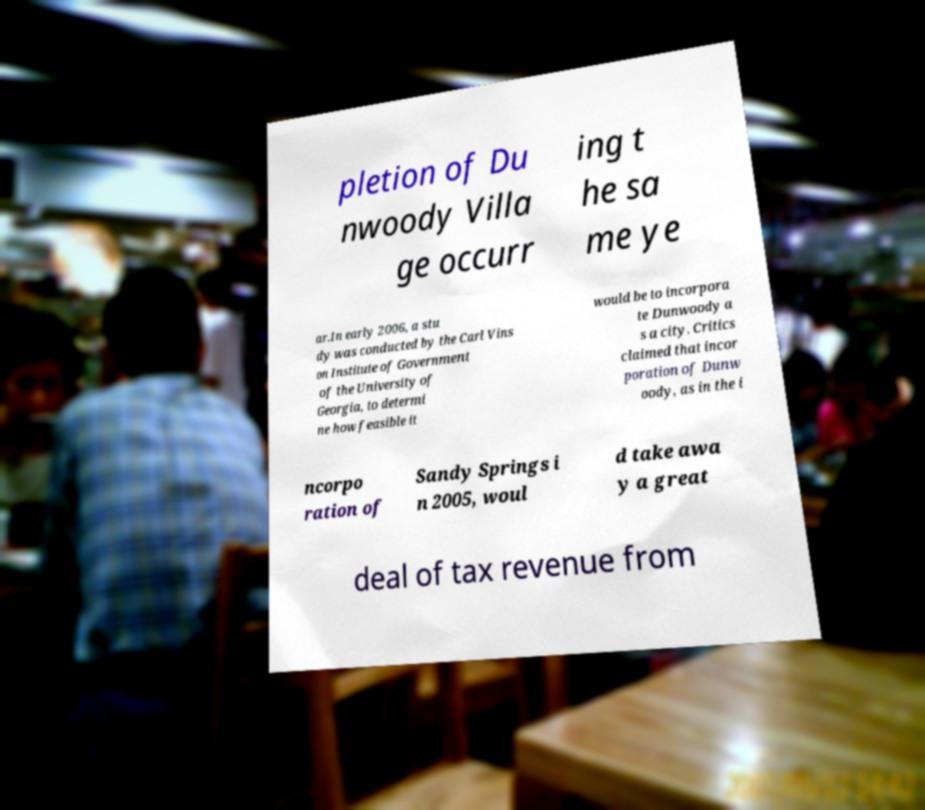For documentation purposes, I need the text within this image transcribed. Could you provide that? pletion of Du nwoody Villa ge occurr ing t he sa me ye ar.In early 2006, a stu dy was conducted by the Carl Vins on Institute of Government of the University of Georgia, to determi ne how feasible it would be to incorpora te Dunwoody a s a city. Critics claimed that incor poration of Dunw oody, as in the i ncorpo ration of Sandy Springs i n 2005, woul d take awa y a great deal of tax revenue from 